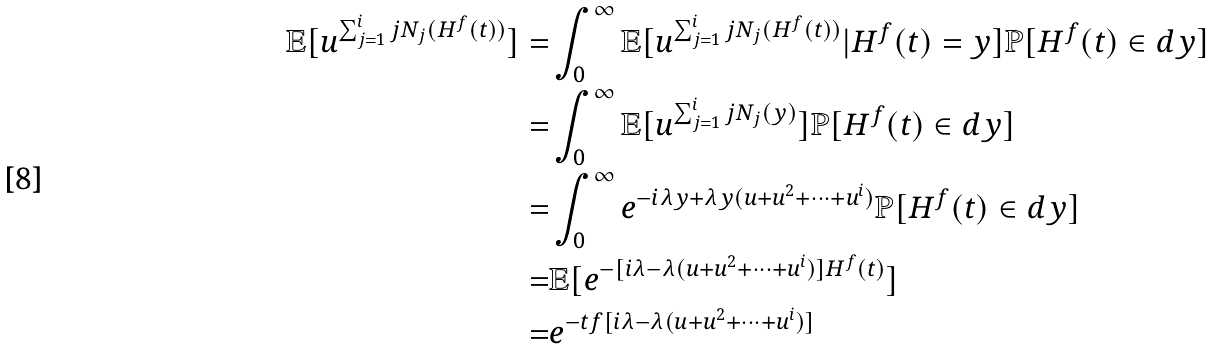Convert formula to latex. <formula><loc_0><loc_0><loc_500><loc_500>\mathbb { E } [ u ^ { \sum _ { j = 1 } ^ { i } j N _ { j } ( H ^ { f } ( t ) ) } ] = & \int _ { 0 } ^ { \infty } \mathbb { E } [ u ^ { \sum _ { j = 1 } ^ { i } j N _ { j } ( H ^ { f } ( t ) ) } | H ^ { f } ( t ) = y ] \mathbb { P } [ H ^ { f } ( t ) \in d y ] \\ = & \int _ { 0 } ^ { \infty } \mathbb { E } [ u ^ { \sum _ { j = 1 } ^ { i } j N _ { j } ( y ) } ] \mathbb { P } [ H ^ { f } ( t ) \in d y ] \\ = & \int _ { 0 } ^ { \infty } e ^ { - i \lambda y + \lambda y ( u + u ^ { 2 } + \dots + u ^ { i } ) } \mathbb { P } [ H ^ { f } ( t ) \in d y ] \\ = & \mathbb { E } [ e ^ { - [ i \lambda - \lambda ( u + u ^ { 2 } + \dots + u ^ { i } ) ] H ^ { f } ( t ) } ] \\ = & e ^ { - t f [ i \lambda - \lambda ( u + u ^ { 2 } + \dots + u ^ { i } ) ] }</formula> 